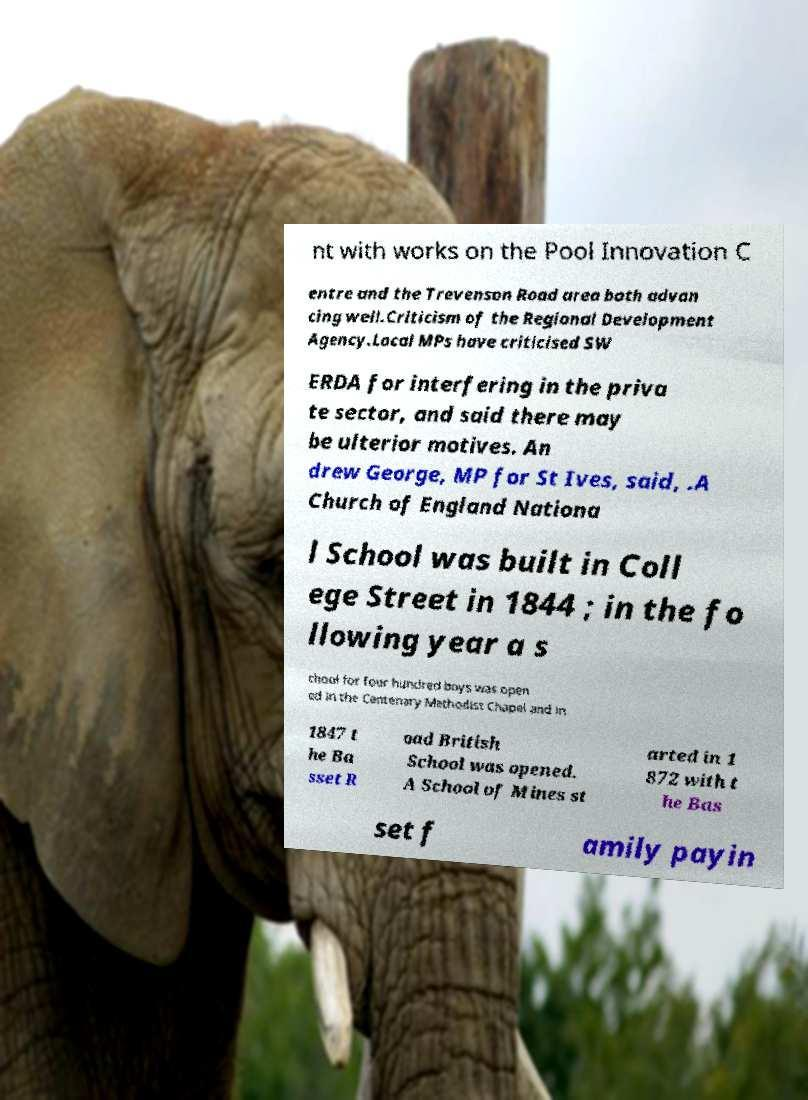What messages or text are displayed in this image? I need them in a readable, typed format. nt with works on the Pool Innovation C entre and the Trevenson Road area both advan cing well.Criticism of the Regional Development Agency.Local MPs have criticised SW ERDA for interfering in the priva te sector, and said there may be ulterior motives. An drew George, MP for St Ives, said, .A Church of England Nationa l School was built in Coll ege Street in 1844 ; in the fo llowing year a s chool for four hundred boys was open ed in the Centenary Methodist Chapel and in 1847 t he Ba sset R oad British School was opened. A School of Mines st arted in 1 872 with t he Bas set f amily payin 